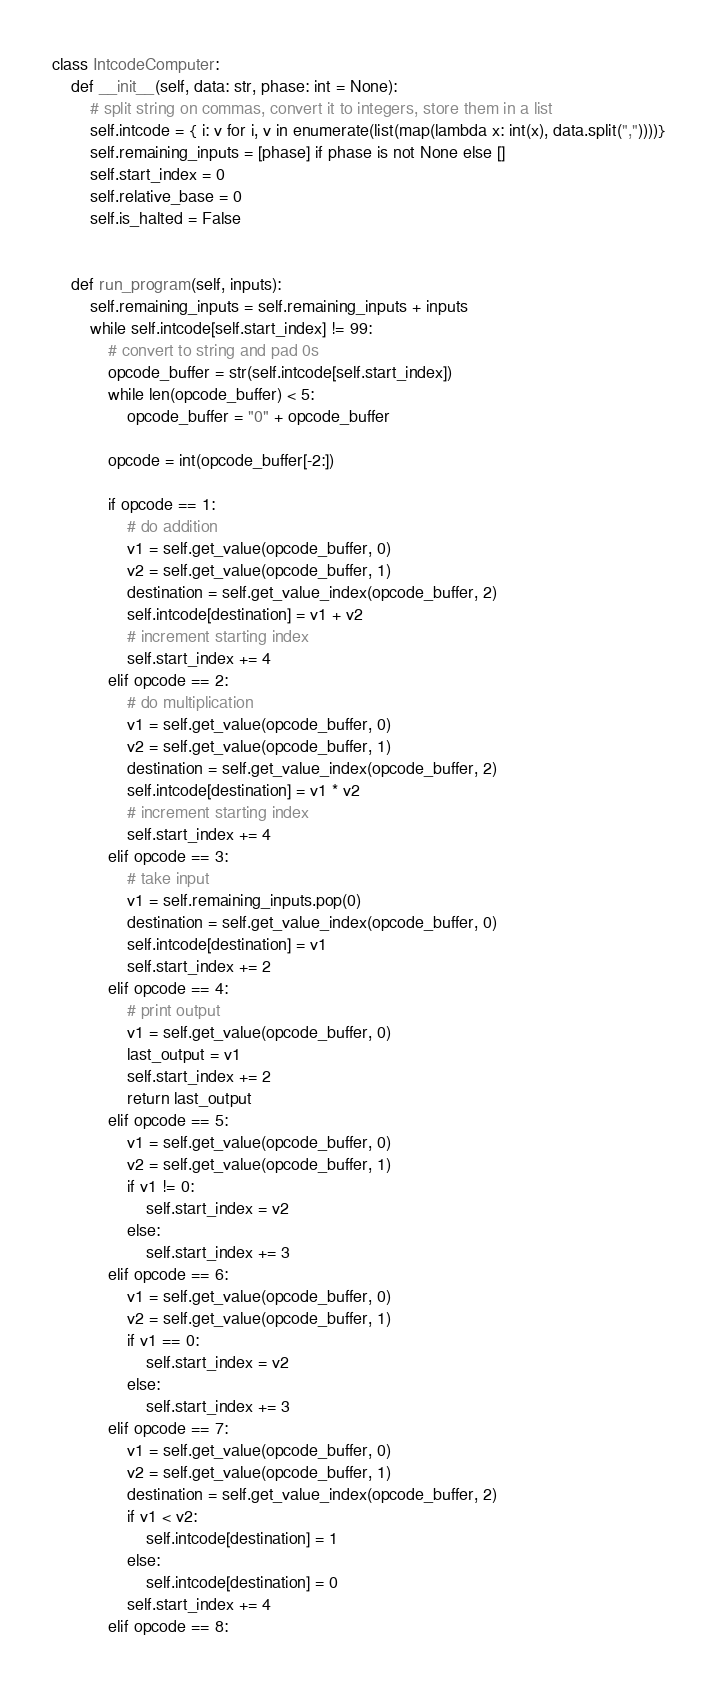Convert code to text. <code><loc_0><loc_0><loc_500><loc_500><_Python_>class IntcodeComputer:
    def __init__(self, data: str, phase: int = None):
        # split string on commas, convert it to integers, store them in a list
        self.intcode = { i: v for i, v in enumerate(list(map(lambda x: int(x), data.split(","))))}
        self.remaining_inputs = [phase] if phase is not None else []
        self.start_index = 0
        self.relative_base = 0
        self.is_halted = False


    def run_program(self, inputs):
        self.remaining_inputs = self.remaining_inputs + inputs
        while self.intcode[self.start_index] != 99:
            # convert to string and pad 0s
            opcode_buffer = str(self.intcode[self.start_index])
            while len(opcode_buffer) < 5:
                opcode_buffer = "0" + opcode_buffer

            opcode = int(opcode_buffer[-2:])

            if opcode == 1:
                # do addition
                v1 = self.get_value(opcode_buffer, 0)
                v2 = self.get_value(opcode_buffer, 1)
                destination = self.get_value_index(opcode_buffer, 2)
                self.intcode[destination] = v1 + v2
                # increment starting index
                self.start_index += 4
            elif opcode == 2:
                # do multiplication
                v1 = self.get_value(opcode_buffer, 0)
                v2 = self.get_value(opcode_buffer, 1)
                destination = self.get_value_index(opcode_buffer, 2)
                self.intcode[destination] = v1 * v2
                # increment starting index
                self.start_index += 4
            elif opcode == 3:
                # take input
                v1 = self.remaining_inputs.pop(0)
                destination = self.get_value_index(opcode_buffer, 0)
                self.intcode[destination] = v1
                self.start_index += 2
            elif opcode == 4:
                # print output
                v1 = self.get_value(opcode_buffer, 0)
                last_output = v1
                self.start_index += 2
                return last_output
            elif opcode == 5:
                v1 = self.get_value(opcode_buffer, 0)
                v2 = self.get_value(opcode_buffer, 1)
                if v1 != 0:
                    self.start_index = v2
                else:
                    self.start_index += 3
            elif opcode == 6:
                v1 = self.get_value(opcode_buffer, 0)
                v2 = self.get_value(opcode_buffer, 1)
                if v1 == 0:
                    self.start_index = v2
                else:
                    self.start_index += 3
            elif opcode == 7:
                v1 = self.get_value(opcode_buffer, 0)
                v2 = self.get_value(opcode_buffer, 1)
                destination = self.get_value_index(opcode_buffer, 2)
                if v1 < v2:
                    self.intcode[destination] = 1
                else:
                    self.intcode[destination] = 0
                self.start_index += 4
            elif opcode == 8:</code> 